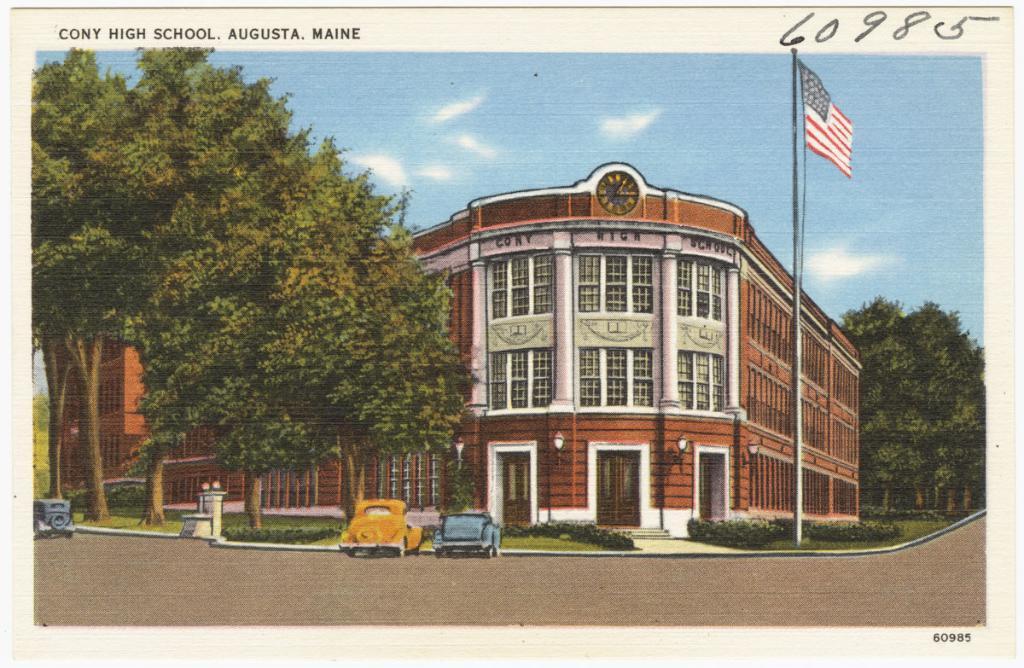Can you describe this image briefly? This image is consists of a poster, in which there is a school building in the center of the image, on which there are many windows, there are cars at the bottom side of the image and there is a flag on the right side of the image and there is greenery in the image. 